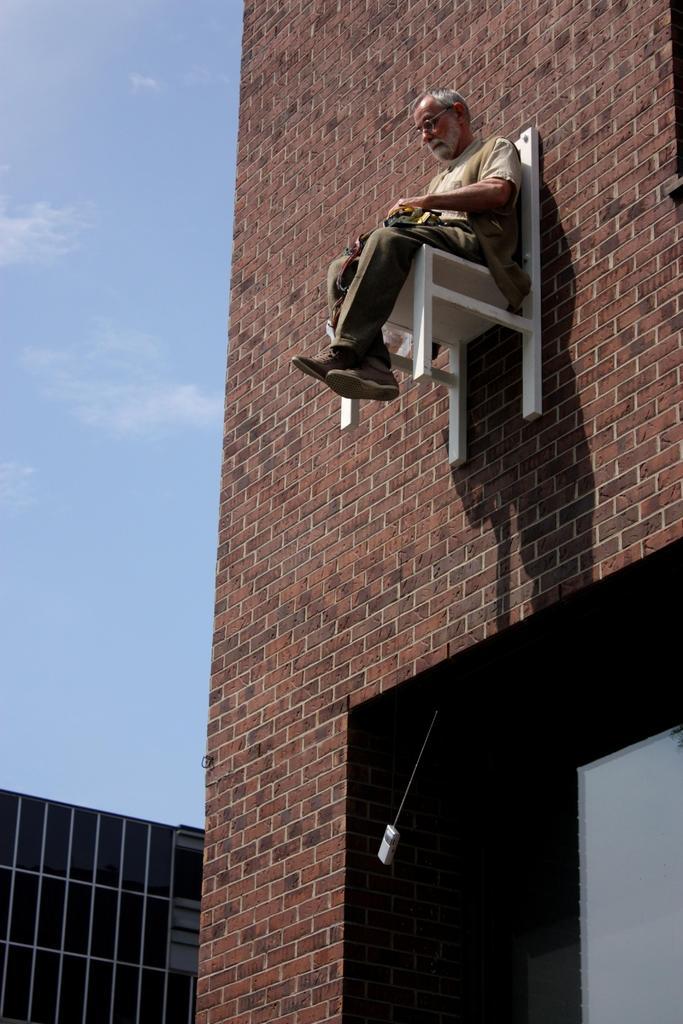Please provide a concise description of this image. In this I can see a man is sitting on the chair, that is stick to this wall, on the left side there is the sky. This man wore shirt, trouser, shoes. 